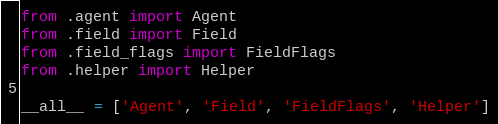<code> <loc_0><loc_0><loc_500><loc_500><_Python_>from .agent import Agent
from .field import Field
from .field_flags import FieldFlags
from .helper import Helper

__all__ = ['Agent', 'Field', 'FieldFlags', 'Helper']
</code> 